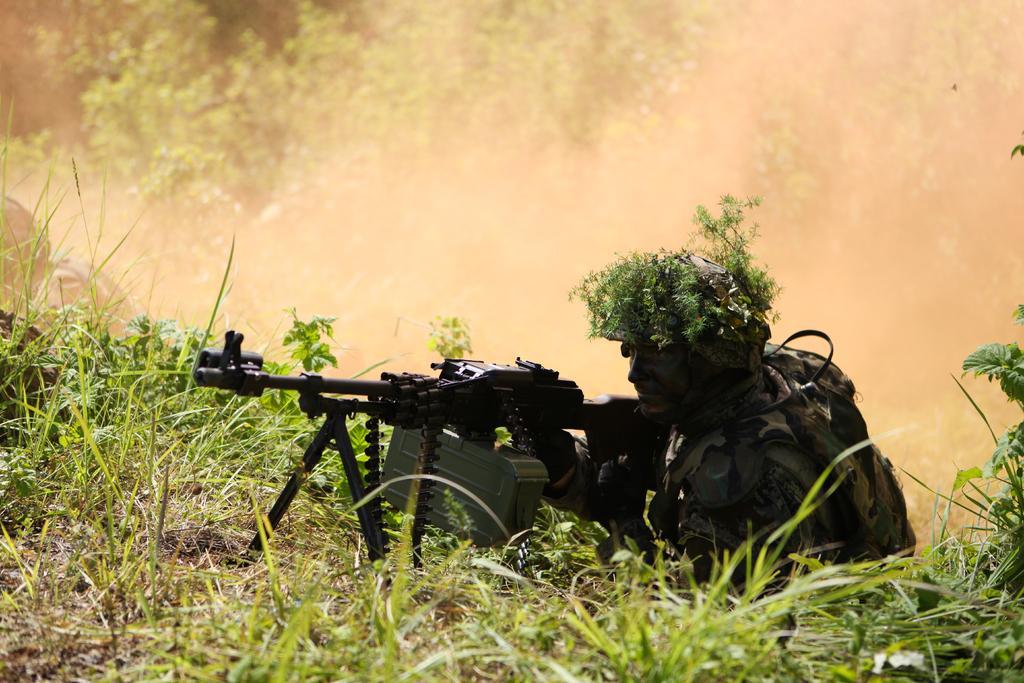Could you give a brief overview of what you see in this image? In the foreground of this image, there is a grass and a man in military dress holding a gun wearing helmet and there is grass on his helmet. In the background, there is smoke and few trees. On the left, there is another person. 